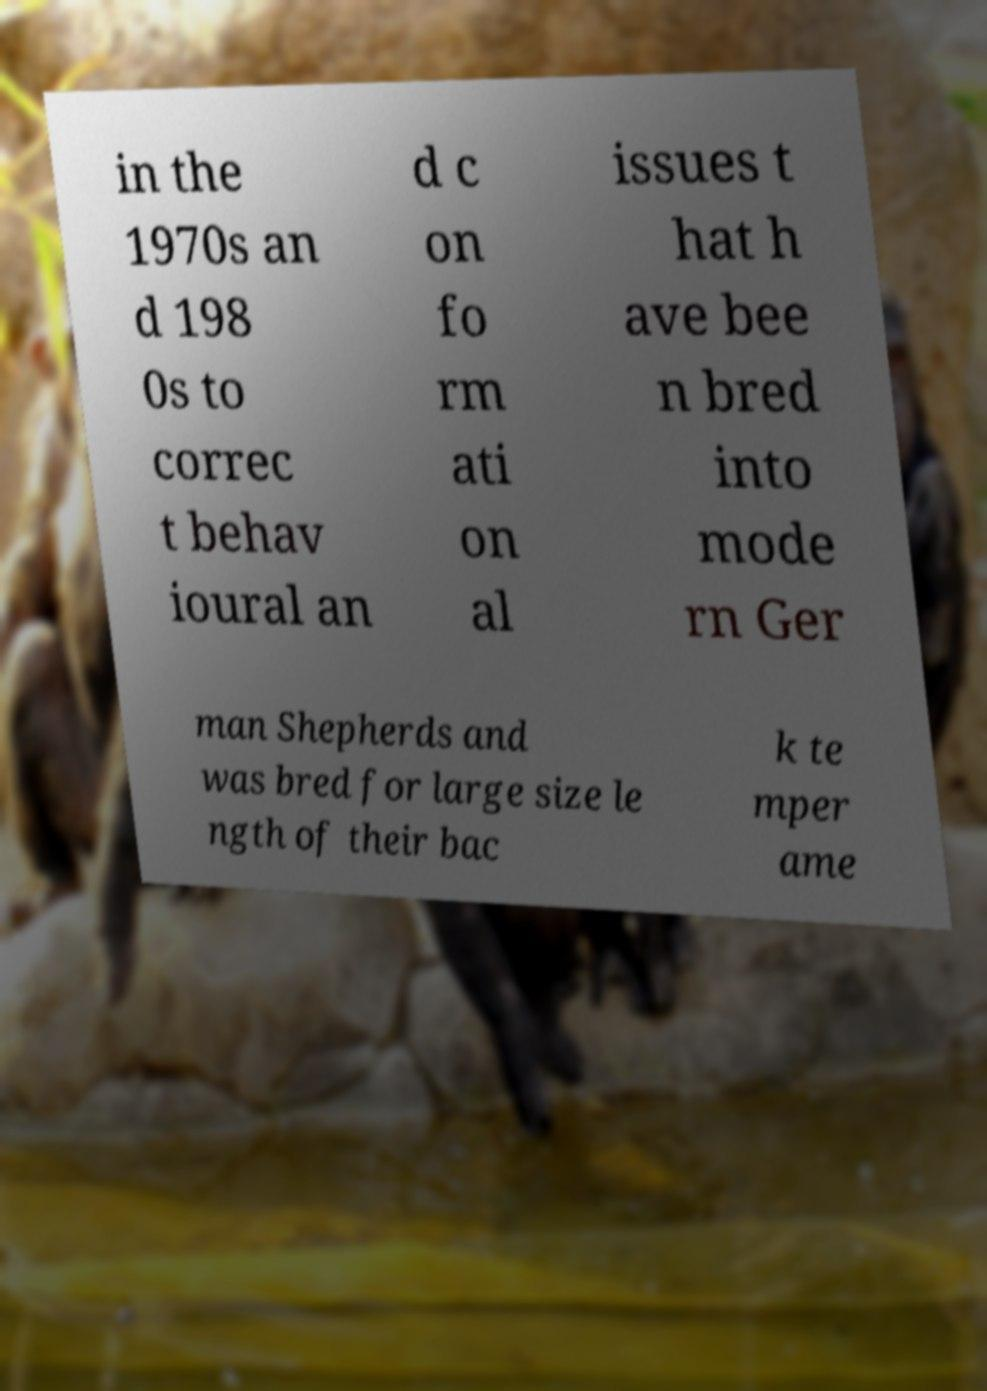I need the written content from this picture converted into text. Can you do that? in the 1970s an d 198 0s to correc t behav ioural an d c on fo rm ati on al issues t hat h ave bee n bred into mode rn Ger man Shepherds and was bred for large size le ngth of their bac k te mper ame 